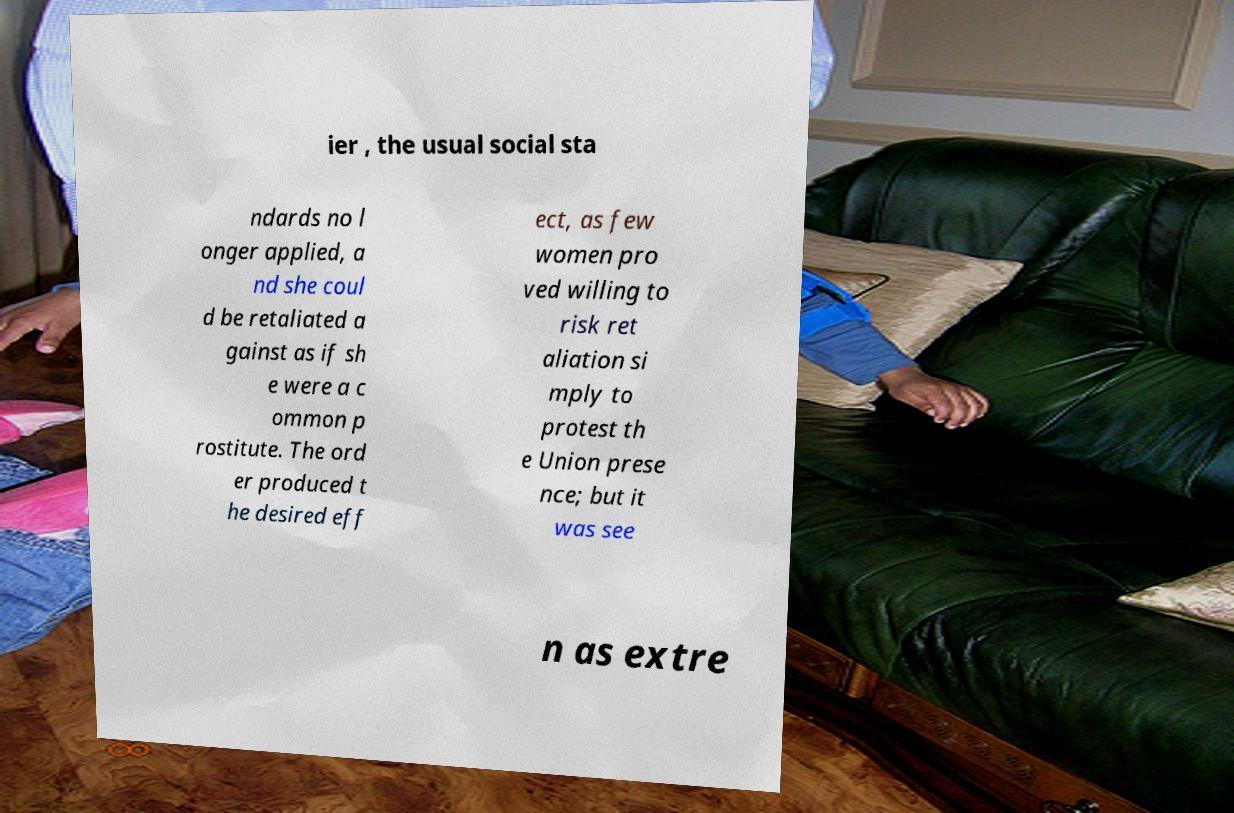For documentation purposes, I need the text within this image transcribed. Could you provide that? ier , the usual social sta ndards no l onger applied, a nd she coul d be retaliated a gainst as if sh e were a c ommon p rostitute. The ord er produced t he desired eff ect, as few women pro ved willing to risk ret aliation si mply to protest th e Union prese nce; but it was see n as extre 